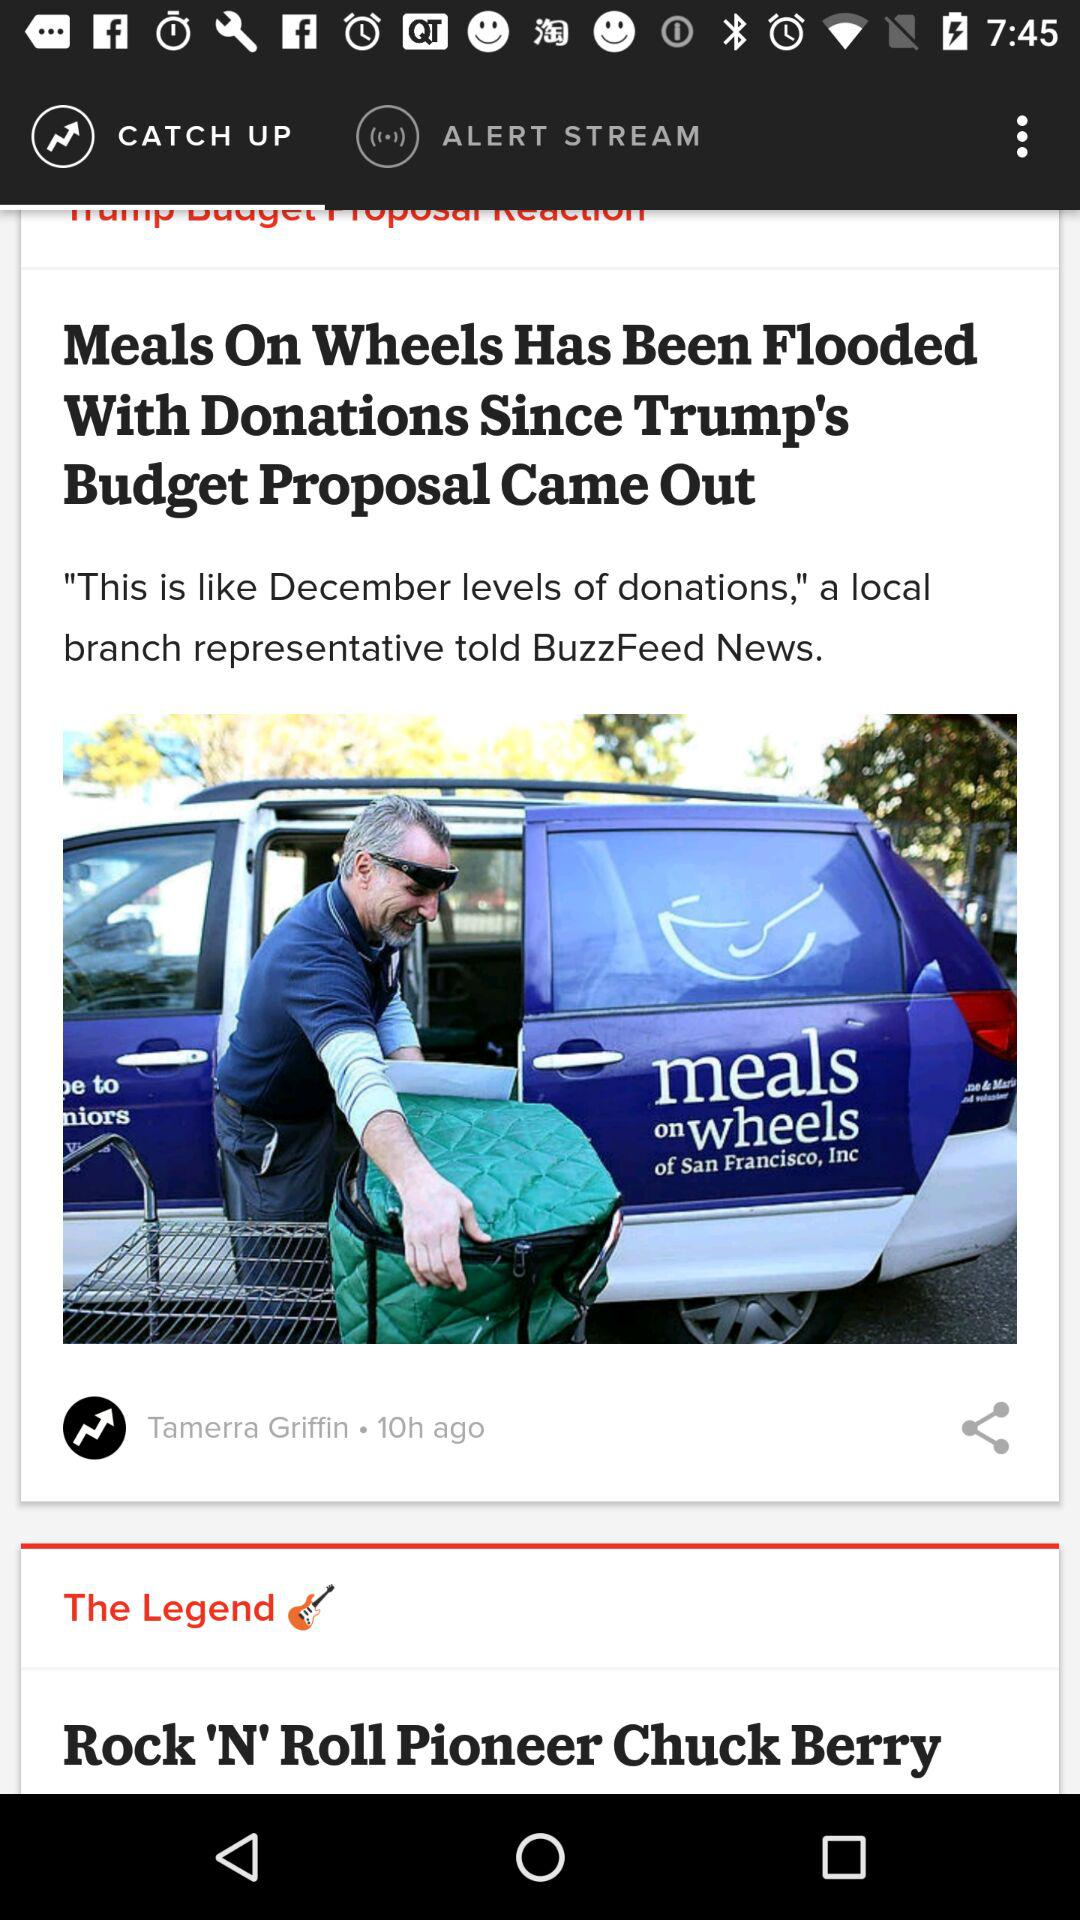When was the news about Meals on Wheels posted? The news was posted 10 hours ago. 